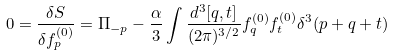Convert formula to latex. <formula><loc_0><loc_0><loc_500><loc_500>0 = \frac { \delta S } { \delta f ^ { ( 0 ) } _ { p } } = \Pi _ { - p } - \frac { \alpha } { 3 } \int \frac { d ^ { 3 } [ q , t ] } { ( 2 \pi ) ^ { 3 / 2 } } f ^ { ( 0 ) } _ { q } f ^ { ( 0 ) } _ { t } \delta ^ { 3 } ( p + q + t )</formula> 